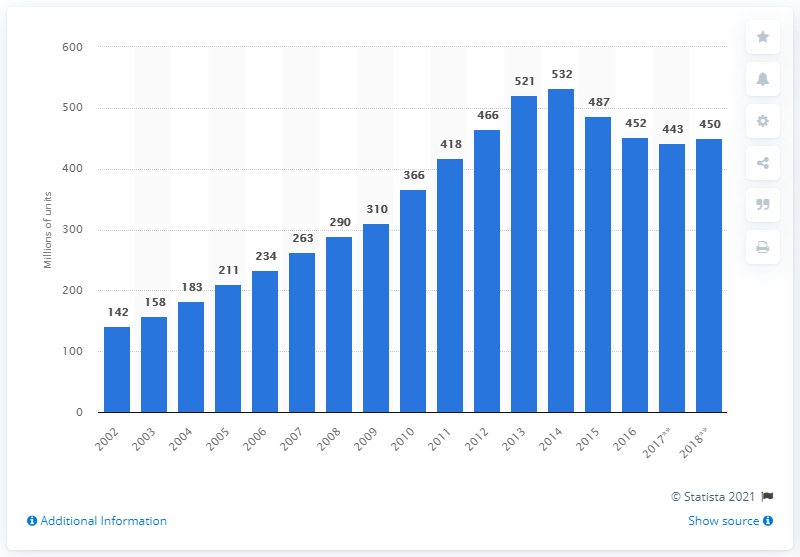Mention a couple of crucial points in this snapshot. In 2016, a total of 450 units of personal computing devices were shipped. 